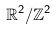<formula> <loc_0><loc_0><loc_500><loc_500>\mathbb { R } ^ { 2 } / \mathbb { Z } ^ { 2 }</formula> 